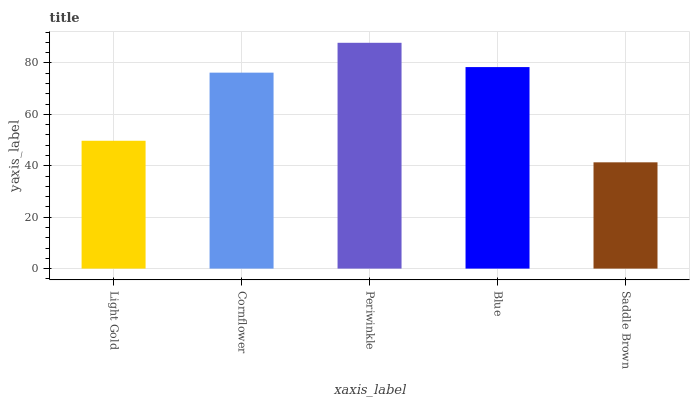Is Saddle Brown the minimum?
Answer yes or no. Yes. Is Periwinkle the maximum?
Answer yes or no. Yes. Is Cornflower the minimum?
Answer yes or no. No. Is Cornflower the maximum?
Answer yes or no. No. Is Cornflower greater than Light Gold?
Answer yes or no. Yes. Is Light Gold less than Cornflower?
Answer yes or no. Yes. Is Light Gold greater than Cornflower?
Answer yes or no. No. Is Cornflower less than Light Gold?
Answer yes or no. No. Is Cornflower the high median?
Answer yes or no. Yes. Is Cornflower the low median?
Answer yes or no. Yes. Is Blue the high median?
Answer yes or no. No. Is Blue the low median?
Answer yes or no. No. 